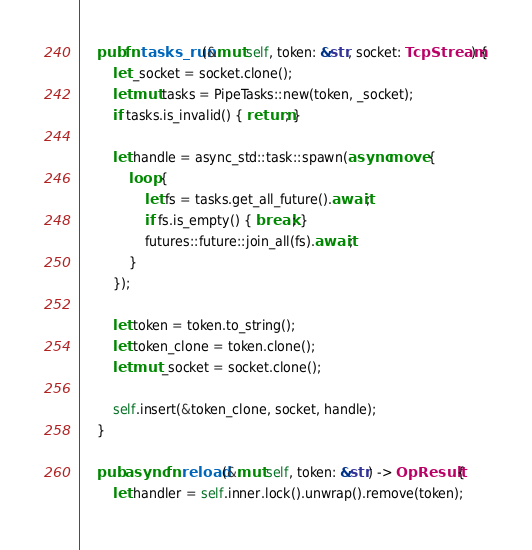Convert code to text. <code><loc_0><loc_0><loc_500><loc_500><_Rust_>    pub fn tasks_run(&mut self, token: &str, socket: TcpStream) {
        let _socket = socket.clone();
        let mut tasks = PipeTasks::new(token, _socket);
        if tasks.is_invalid() { return; }

        let handle = async_std::task::spawn(async move {
            loop {
                let fs = tasks.get_all_future().await;
                if fs.is_empty() { break; }
                futures::future::join_all(fs).await;
            }
        });

        let token = token.to_string();
        let token_clone = token.clone();
        let mut _socket = socket.clone();

        self.insert(&token_clone, socket, handle);
    }

    pub async fn reload(&mut self, token: &str) -> OpResult {
        let handler = self.inner.lock().unwrap().remove(token);</code> 